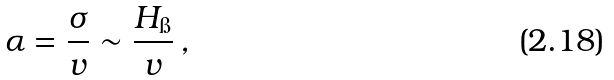<formula> <loc_0><loc_0><loc_500><loc_500>\alpha = \frac { \sigma } { v } \sim \frac { H _ { \i } } { v } \, ,</formula> 